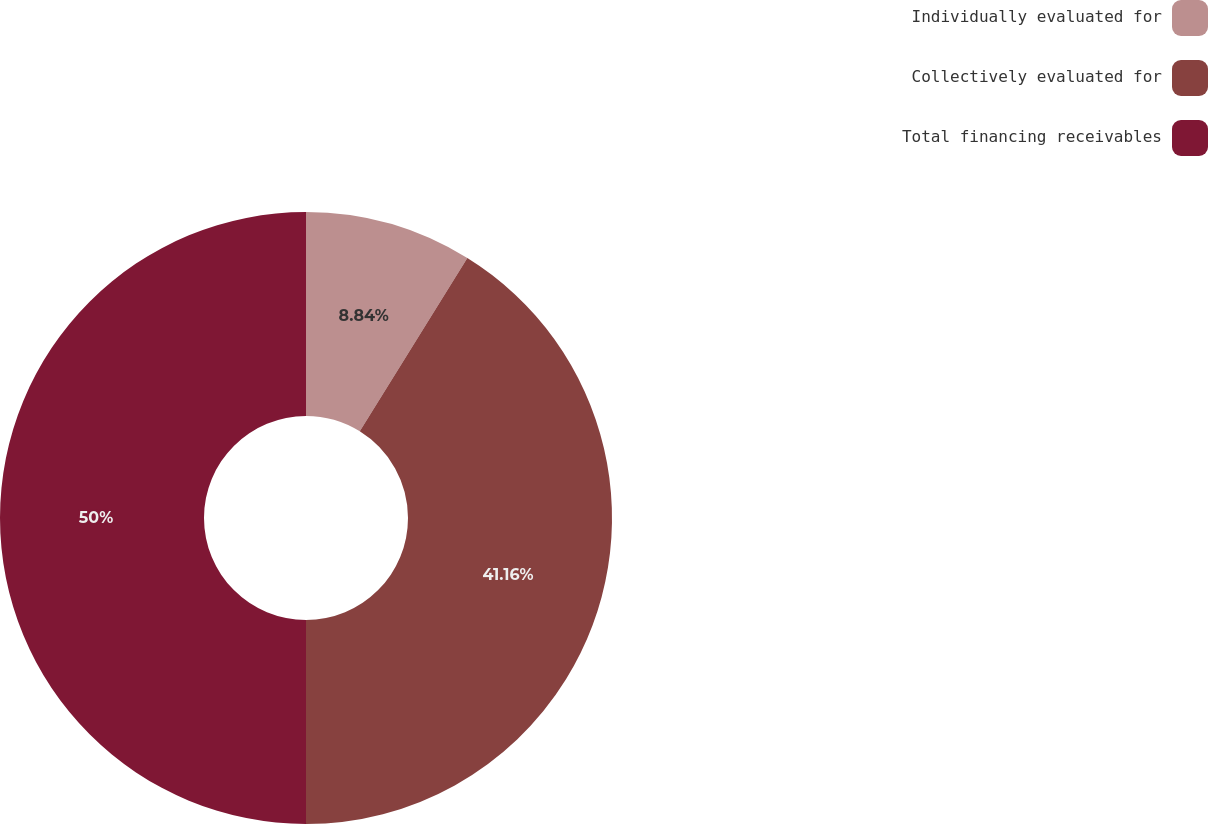Convert chart. <chart><loc_0><loc_0><loc_500><loc_500><pie_chart><fcel>Individually evaluated for<fcel>Collectively evaluated for<fcel>Total financing receivables<nl><fcel>8.84%<fcel>41.16%<fcel>50.0%<nl></chart> 